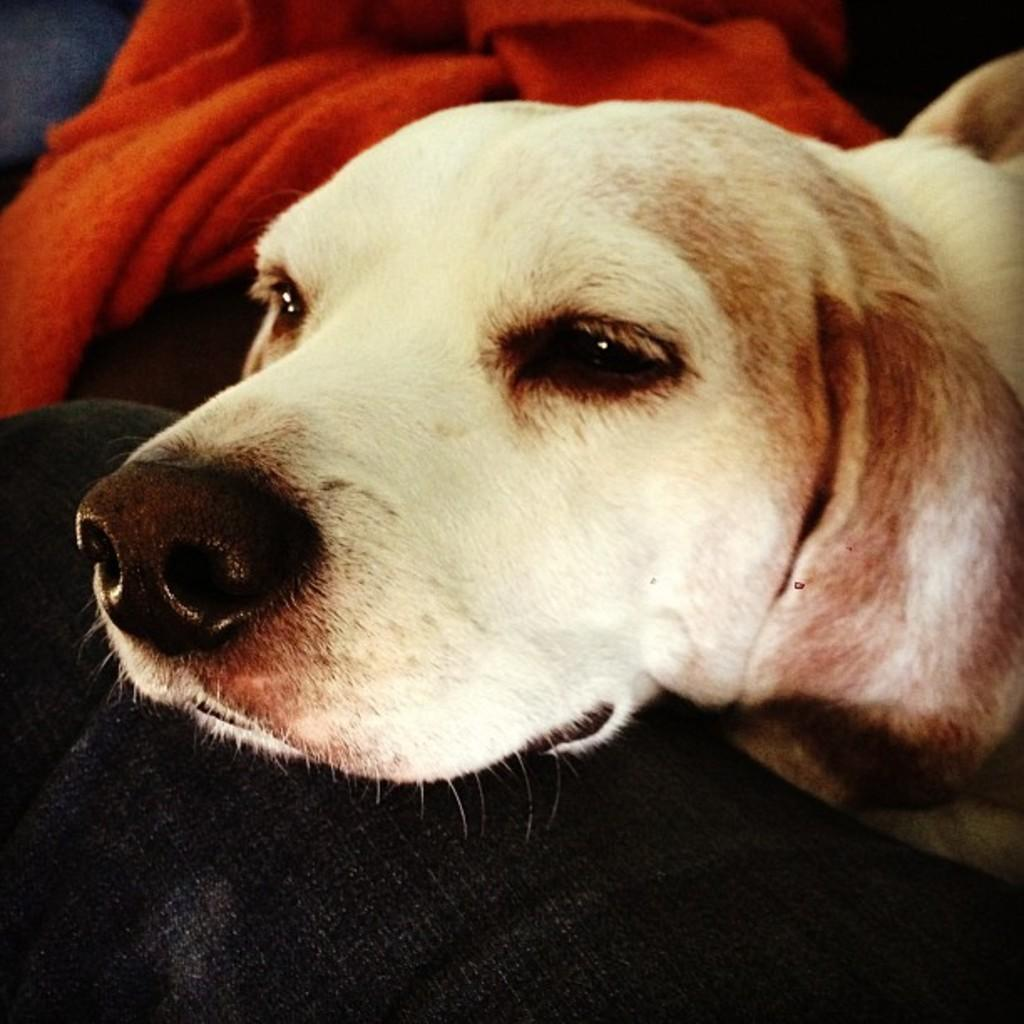What type of animal is in the image? There is a dog in the image. Where is the dog located in the image? The dog is on a person's leg. What else can be seen at the top of the image? There is a cloth visible at the top of the image. What type of quiver is the dog carrying on its back in the image? There is no quiver present in the image; the dog is simply on a person's leg. 